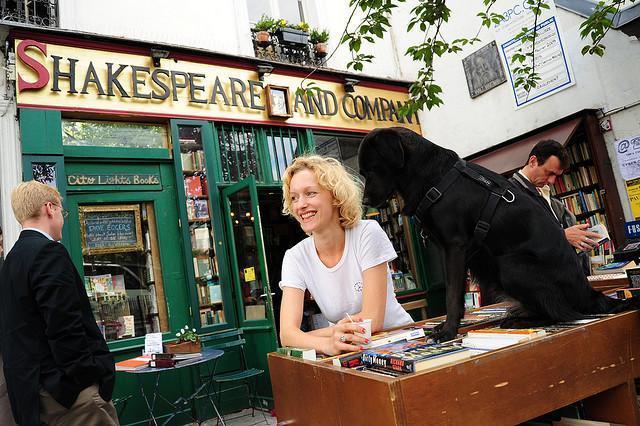How many people are there?
Give a very brief answer. 3. How many books can you see?
Give a very brief answer. 2. 